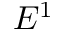Convert formula to latex. <formula><loc_0><loc_0><loc_500><loc_500>E ^ { 1 }</formula> 